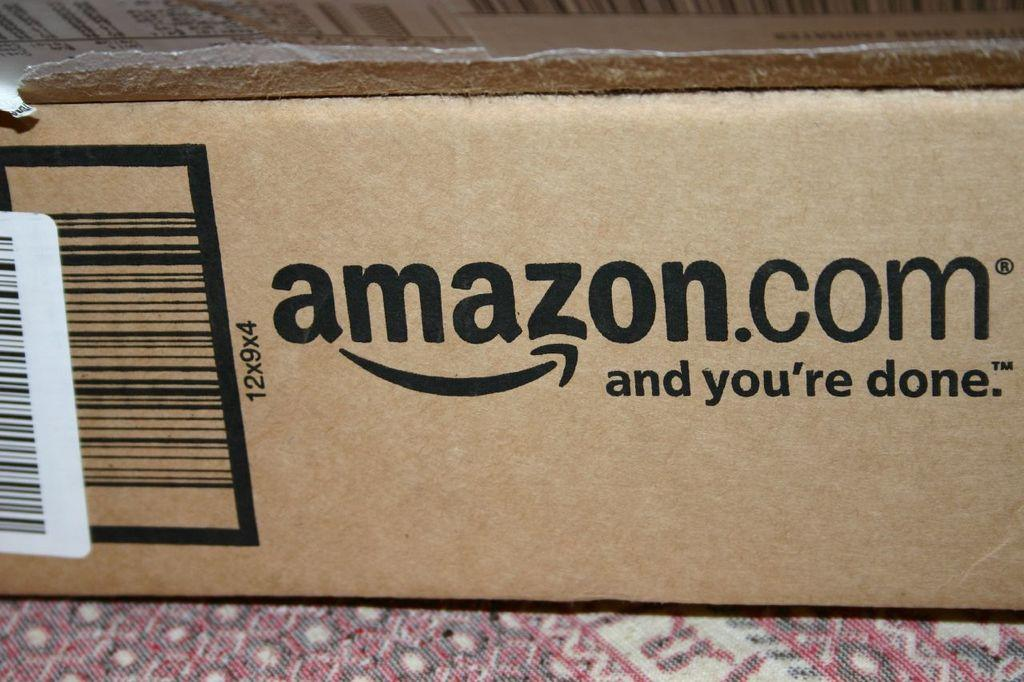Provide a one-sentence caption for the provided image. An Amazon box is sitting on a multicolored surface. 